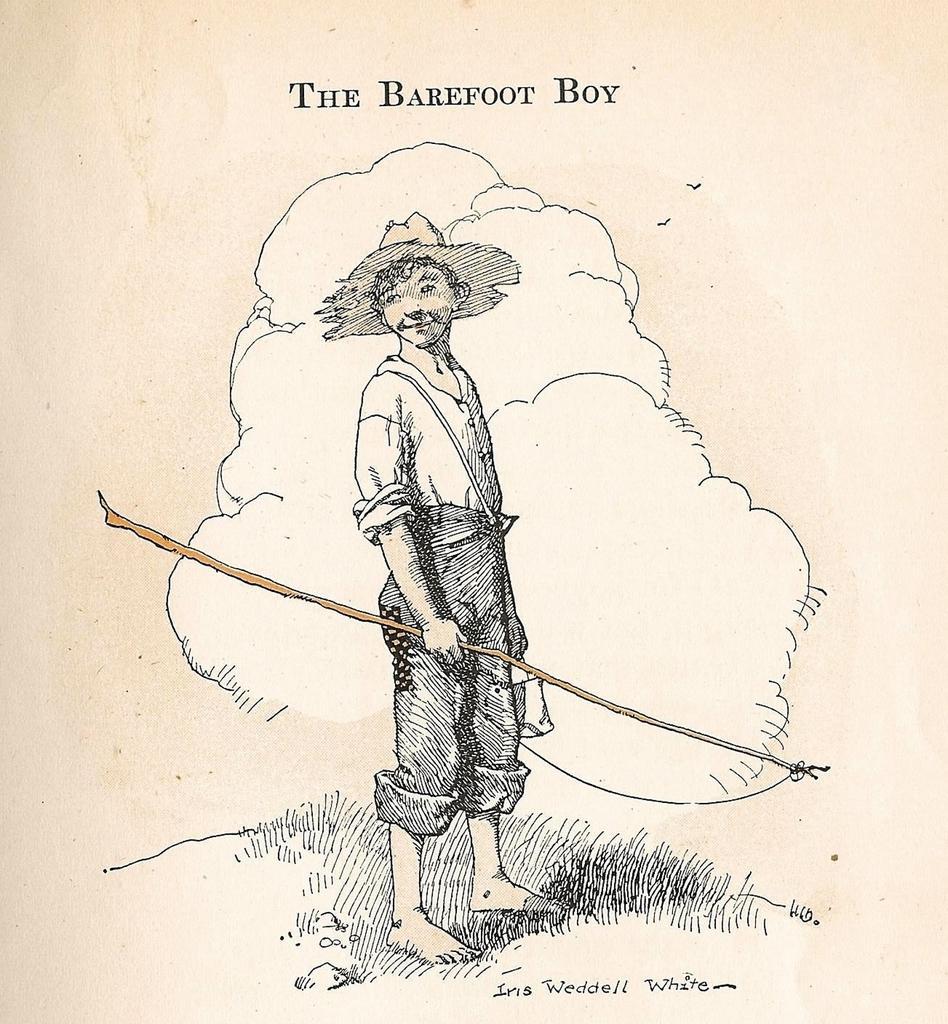Describe this image in one or two sentences. In this picture we can see poster. In that there is a man who is wearing hat, shirt, trouser and holding a stick. At the top there is a quotation. 